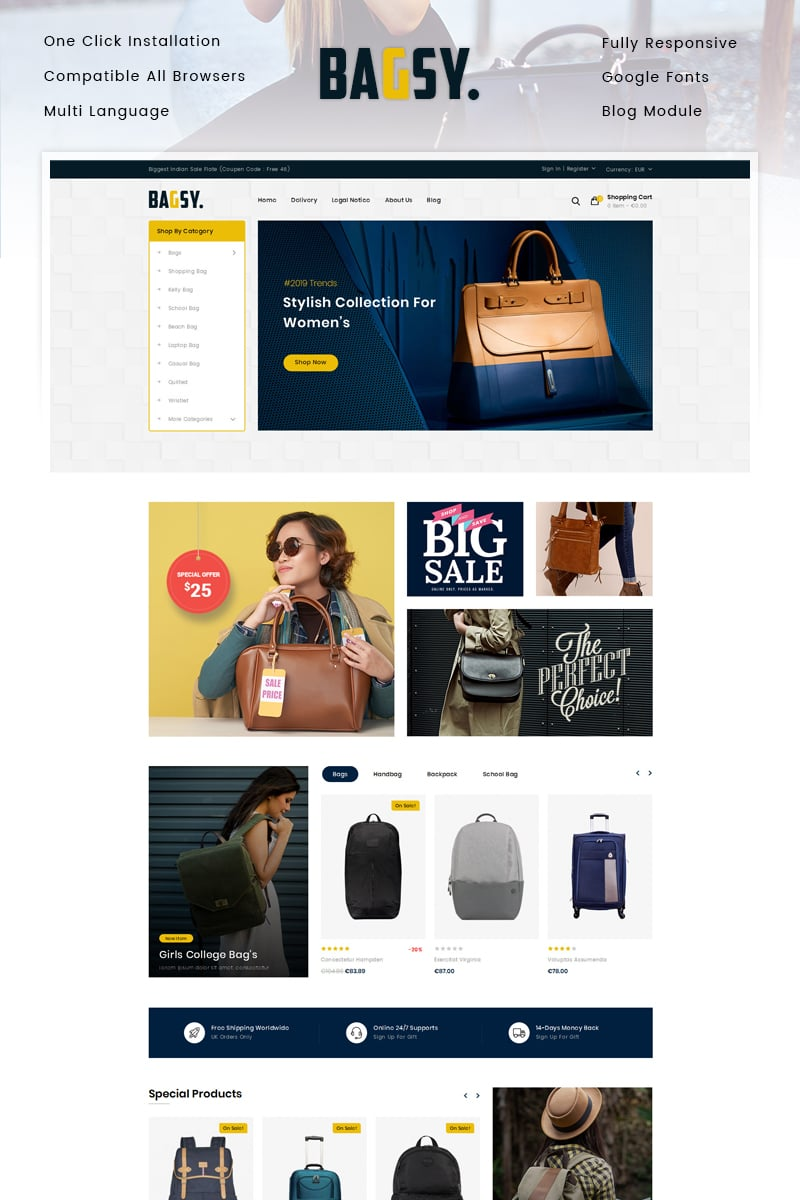What specific design elements in the promotional banners help in attracting the target demographic? The promotional banners utilize vibrant, eye-catching colors like deep blues and bright yellows, which grab the viewer’s attention. Additionally, the modern, clean typography and dynamic poses of the models, who exhibit a sense of confidence and style, likely resonate well with young, fashion-forward women. The banners also cleverly highlight the affordability and stylishness of the products, two key considerations for the target demographic. 